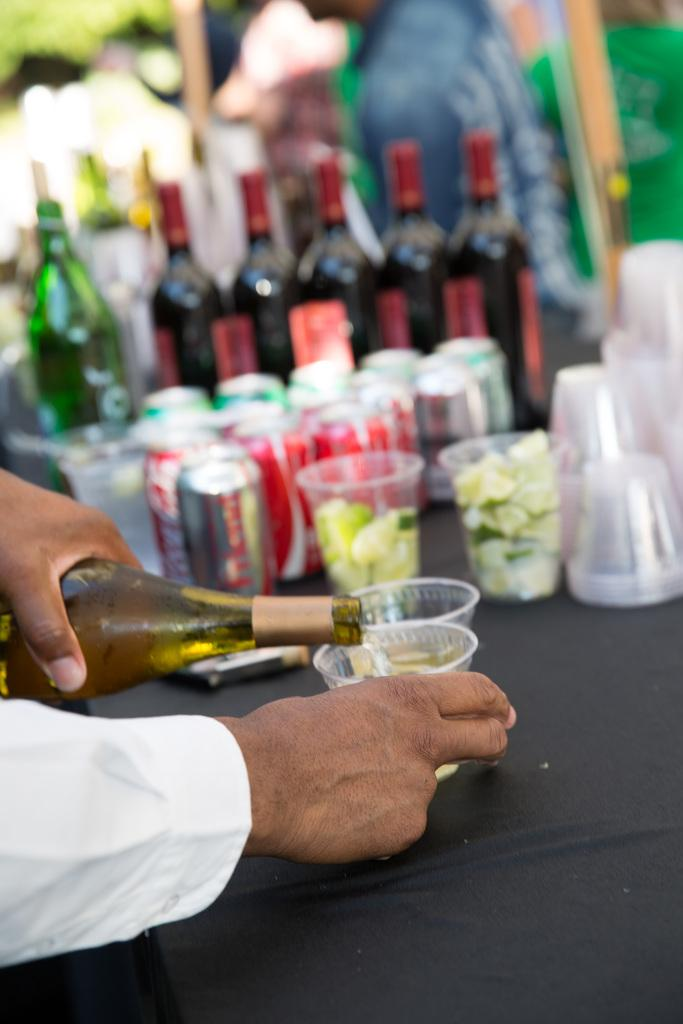<image>
Provide a brief description of the given image. A server pours white wine into a glass sitting on an outdoor bar, other wine bottles, garnishes and cans of coke in the background. 